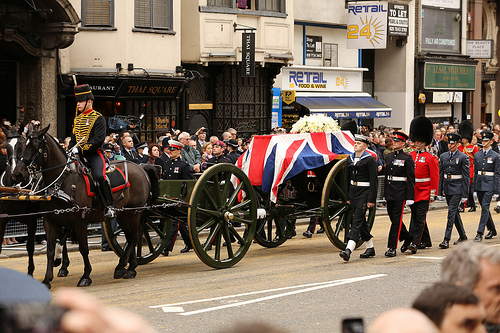Is the green vehicle to the right of a man? No, the green vehicle is not to the right of the man. 